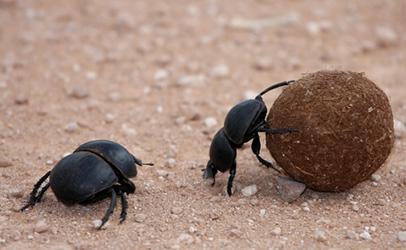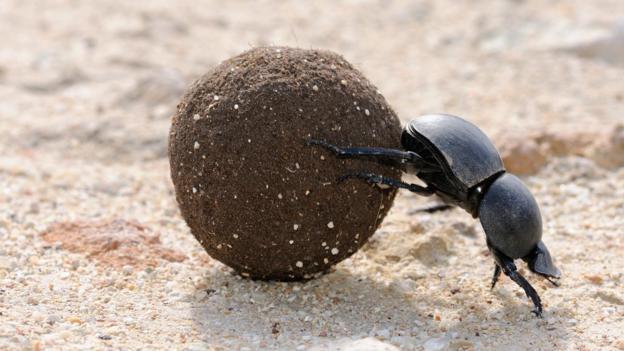The first image is the image on the left, the second image is the image on the right. Considering the images on both sides, is "There are two beetles near one clod of dirt in one of the images." valid? Answer yes or no. Yes. The first image is the image on the left, the second image is the image on the right. Evaluate the accuracy of this statement regarding the images: "Each image includes a beetle with a dungball that is bigger than the beetle.". Is it true? Answer yes or no. Yes. 